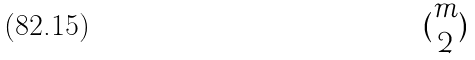<formula> <loc_0><loc_0><loc_500><loc_500>( \begin{matrix} m \\ 2 \end{matrix} )</formula> 